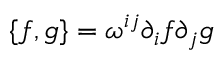Convert formula to latex. <formula><loc_0><loc_0><loc_500><loc_500>\{ f , g \} = \omega ^ { i j } \partial _ { i } f \partial _ { j } g</formula> 